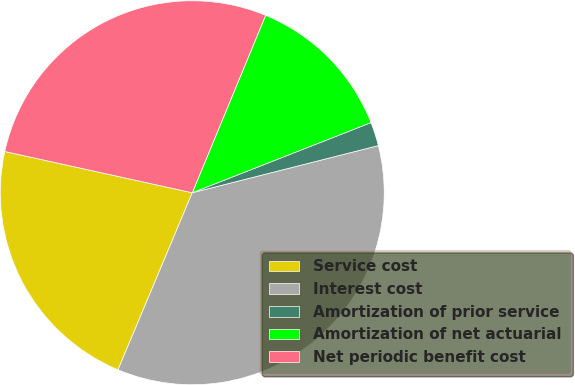Convert chart. <chart><loc_0><loc_0><loc_500><loc_500><pie_chart><fcel>Service cost<fcel>Interest cost<fcel>Amortization of prior service<fcel>Amortization of net actuarial<fcel>Net periodic benefit cost<nl><fcel>22.13%<fcel>35.27%<fcel>2.0%<fcel>12.81%<fcel>27.79%<nl></chart> 